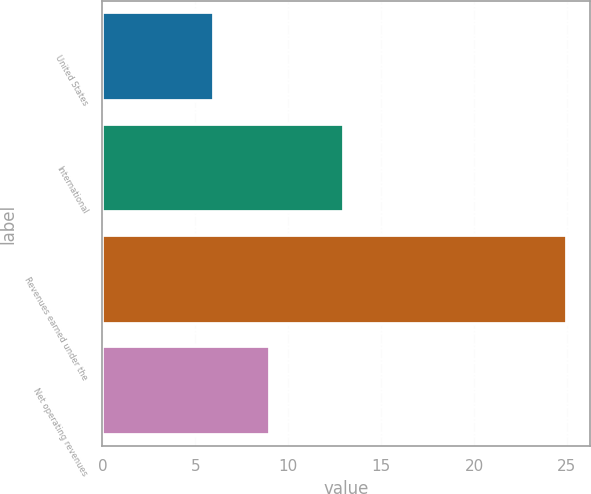<chart> <loc_0><loc_0><loc_500><loc_500><bar_chart><fcel>United States<fcel>International<fcel>Revenues earned under the<fcel>Net operating revenues<nl><fcel>6<fcel>13<fcel>25<fcel>9<nl></chart> 